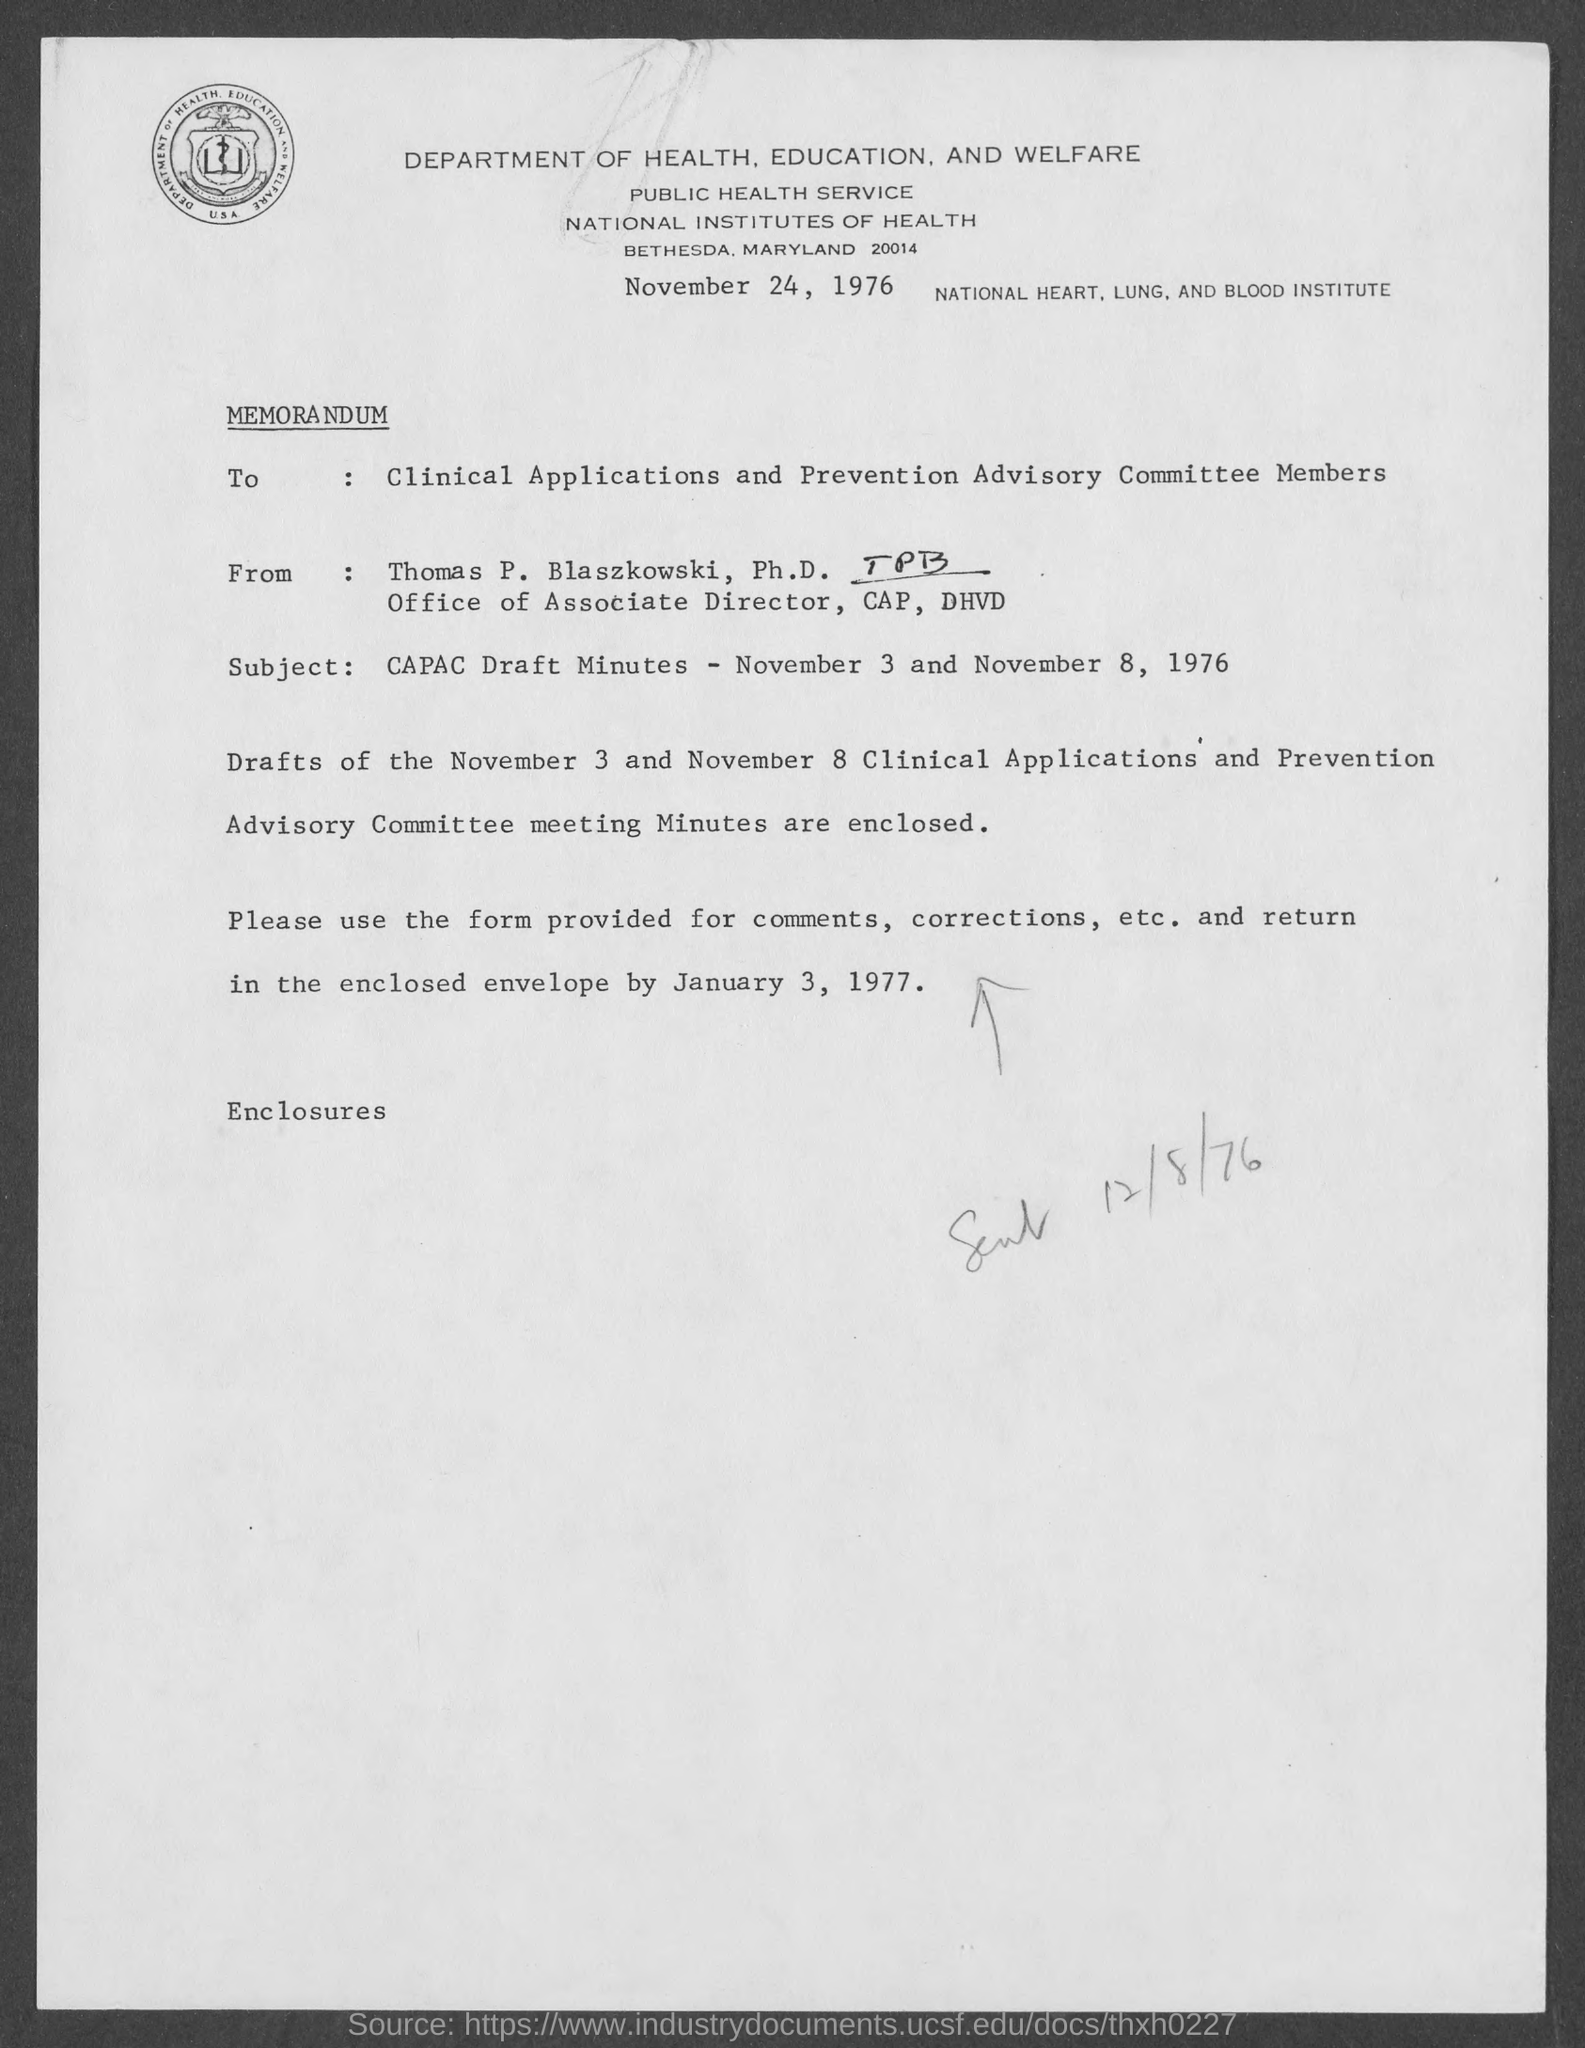Draw attention to some important aspects in this diagram. Who wrote the letter? Thomas P. Blaszkowski wrote the letter. The letter is addressed to the Clinical Applications and Prevention Advisory Committee Members. The subject of the sentence is "What is written. 